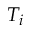<formula> <loc_0><loc_0><loc_500><loc_500>T _ { i }</formula> 